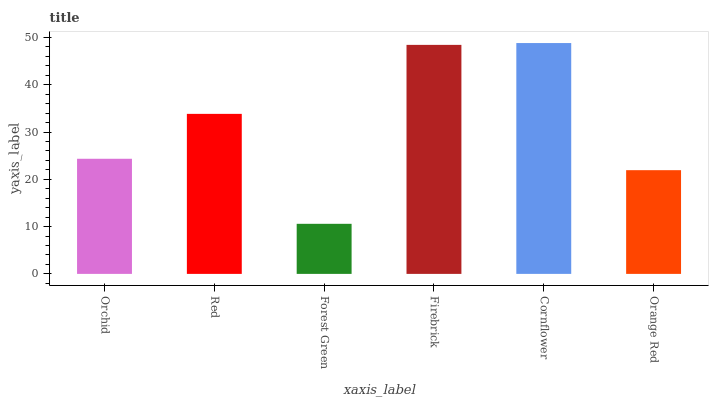Is Forest Green the minimum?
Answer yes or no. Yes. Is Cornflower the maximum?
Answer yes or no. Yes. Is Red the minimum?
Answer yes or no. No. Is Red the maximum?
Answer yes or no. No. Is Red greater than Orchid?
Answer yes or no. Yes. Is Orchid less than Red?
Answer yes or no. Yes. Is Orchid greater than Red?
Answer yes or no. No. Is Red less than Orchid?
Answer yes or no. No. Is Red the high median?
Answer yes or no. Yes. Is Orchid the low median?
Answer yes or no. Yes. Is Orange Red the high median?
Answer yes or no. No. Is Firebrick the low median?
Answer yes or no. No. 